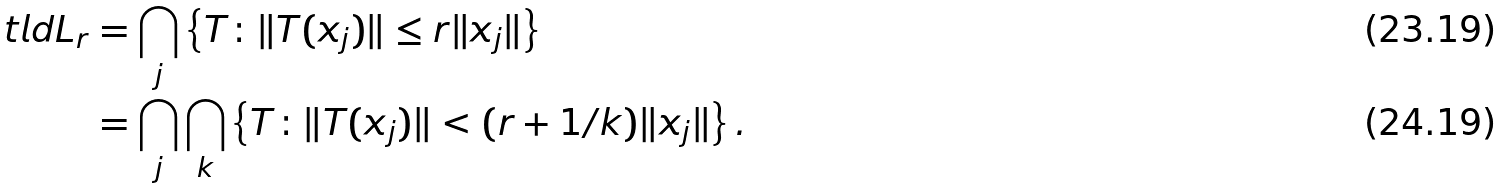<formula> <loc_0><loc_0><loc_500><loc_500>\ t l d { L } _ { r } & = \bigcap _ { j } \left \{ T \colon \| T ( x _ { j } ) \| \leq r \| x _ { j } \| \right \} \\ & = \bigcap _ { j } \bigcap _ { k } \left \{ T \colon \| T ( x _ { j } ) \| < ( r + 1 / k ) \| x _ { j } \| \right \} .</formula> 